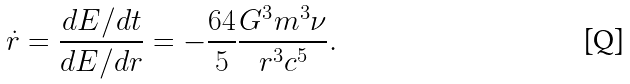<formula> <loc_0><loc_0><loc_500><loc_500>\dot { r } = \frac { d E / d t } { d E / d r } = - \frac { 6 4 } { 5 } \frac { G ^ { 3 } m ^ { 3 } \nu } { r ^ { 3 } c ^ { 5 } } .</formula> 